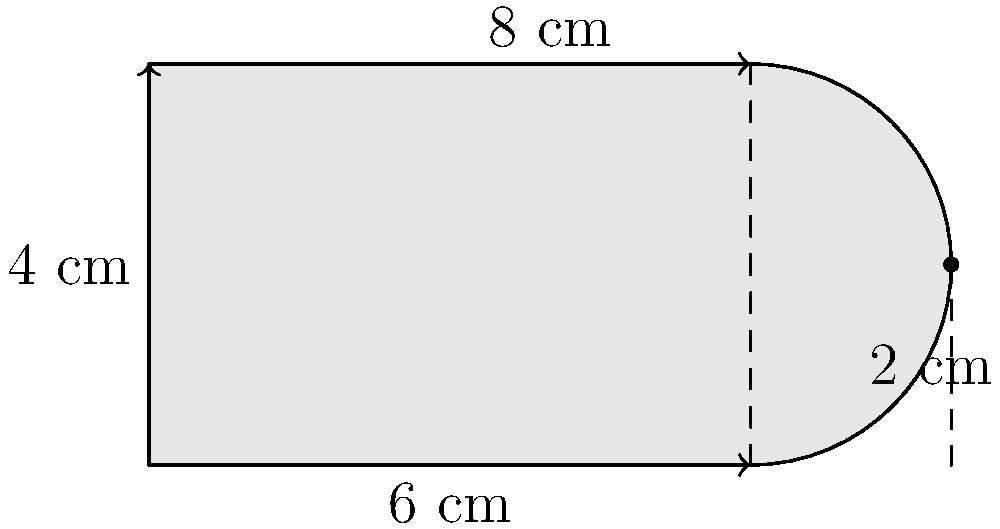As an engineer in the motorsports industry, you're tasked with designing a custom fuel tank for a high-performance race car. The tank has an irregular shape to fit the car's chassis, as shown in the diagram. The straight sides are 6 cm and 4 cm, and the curved section extends 2 cm beyond the 6 cm side at its widest point. The curve can be approximated as a semicircle. Calculate the total area of this fuel tank in square centimeters. To find the area of this irregular shape, we'll break it down into two parts: a rectangle and a semicircle.

1. Area of the rectangle:
   $A_{rectangle} = 6 \text{ cm} \times 4 \text{ cm} = 24 \text{ cm}^2$

2. Area of the semicircle:
   - The diameter of the semicircle is 4 cm (the height of the shape)
   - Radius of the semicircle: $r = 4 \text{ cm} / 2 = 2 \text{ cm}$
   - Area of a full circle: $A_{circle} = \pi r^2 = \pi (2 \text{ cm})^2 = 4\pi \text{ cm}^2$
   - Area of the semicircle: $A_{semicircle} = \frac{1}{2} A_{circle} = 2\pi \text{ cm}^2$

3. Total area:
   $A_{total} = A_{rectangle} + A_{semicircle}$
   $A_{total} = 24 \text{ cm}^2 + 2\pi \text{ cm}^2$
   $A_{total} = (24 + 2\pi) \text{ cm}^2$

4. Calculating the final value:
   $A_{total} \approx 30.28 \text{ cm}^2$
Answer: $30.28 \text{ cm}^2$ 